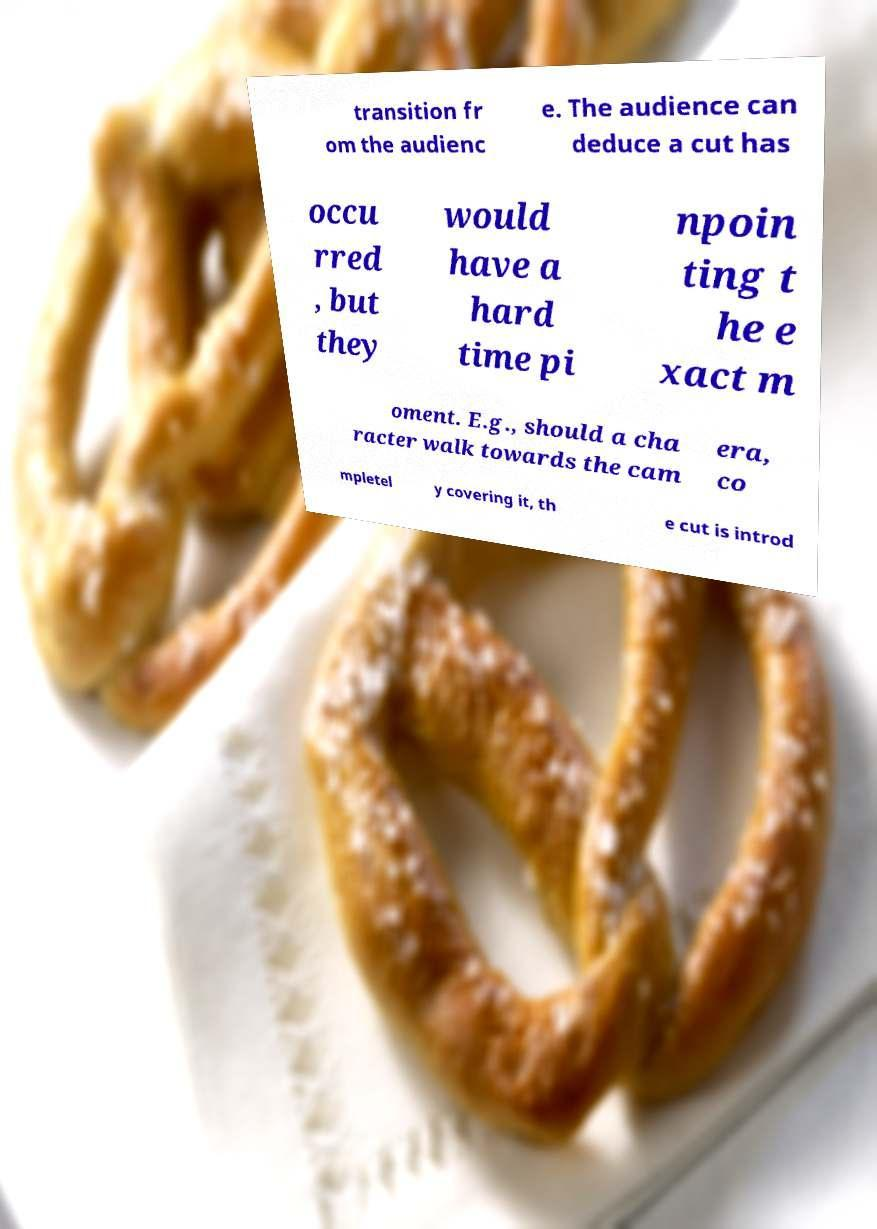Could you assist in decoding the text presented in this image and type it out clearly? transition fr om the audienc e. The audience can deduce a cut has occu rred , but they would have a hard time pi npoin ting t he e xact m oment. E.g., should a cha racter walk towards the cam era, co mpletel y covering it, th e cut is introd 